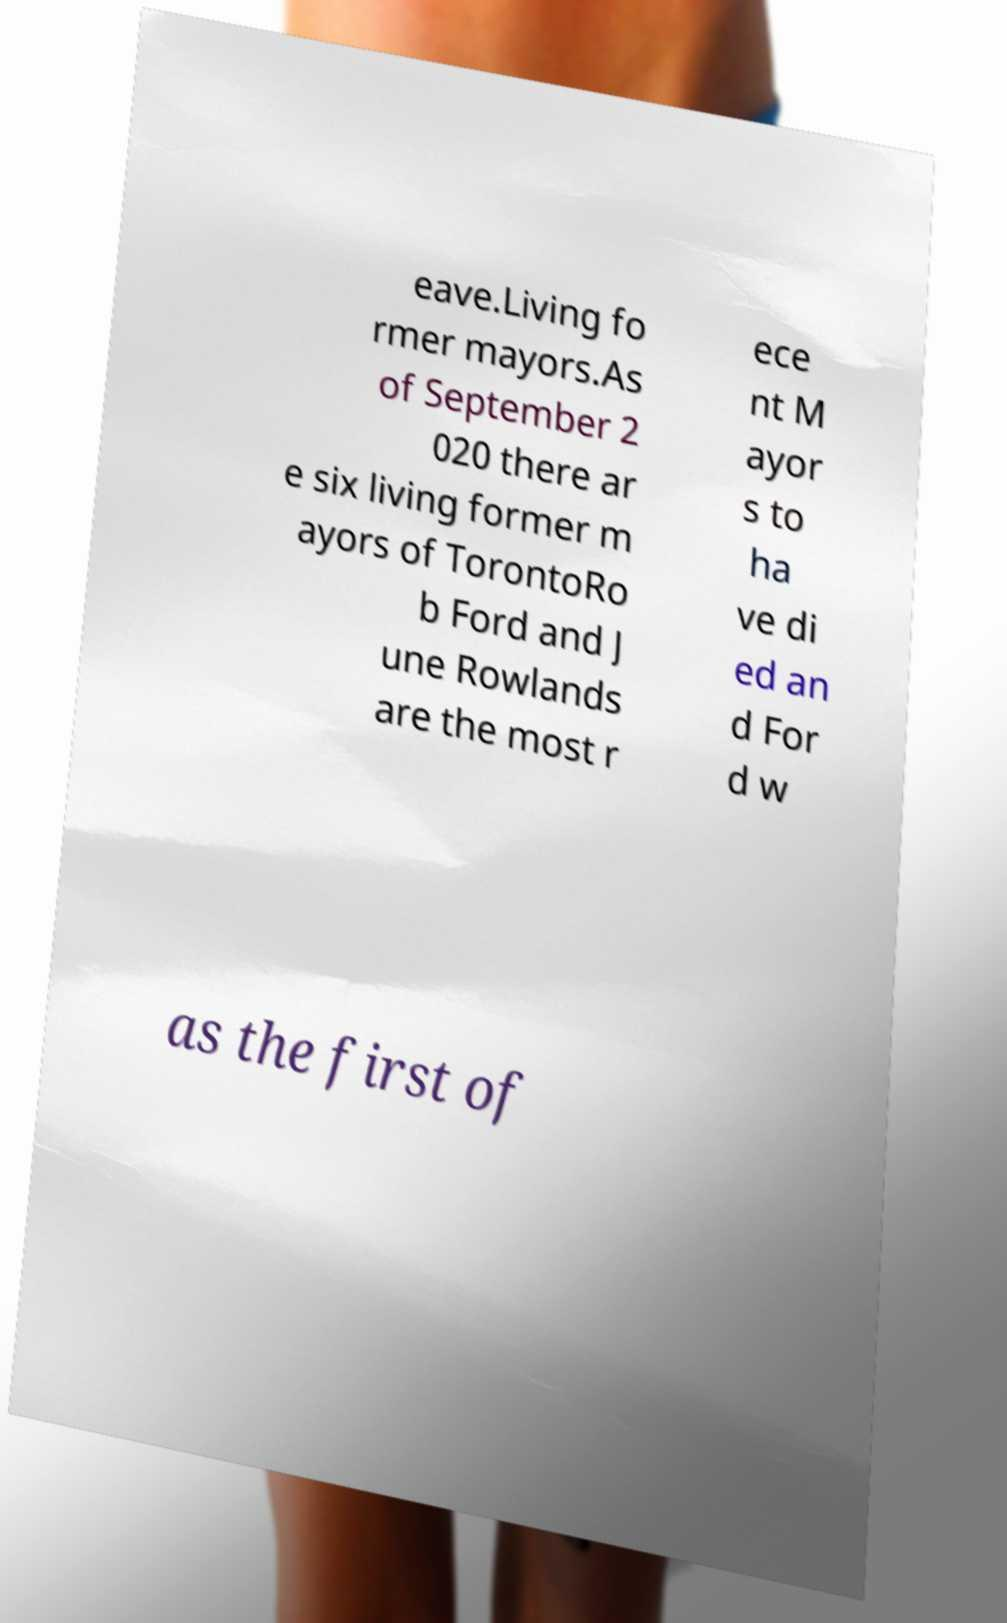I need the written content from this picture converted into text. Can you do that? eave.Living fo rmer mayors.As of September 2 020 there ar e six living former m ayors of TorontoRo b Ford and J une Rowlands are the most r ece nt M ayor s to ha ve di ed an d For d w as the first of 